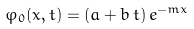<formula> <loc_0><loc_0><loc_500><loc_500>\varphi _ { 0 } ( x , t ) = ( a + b \, t ) \, e ^ { - m x }</formula> 